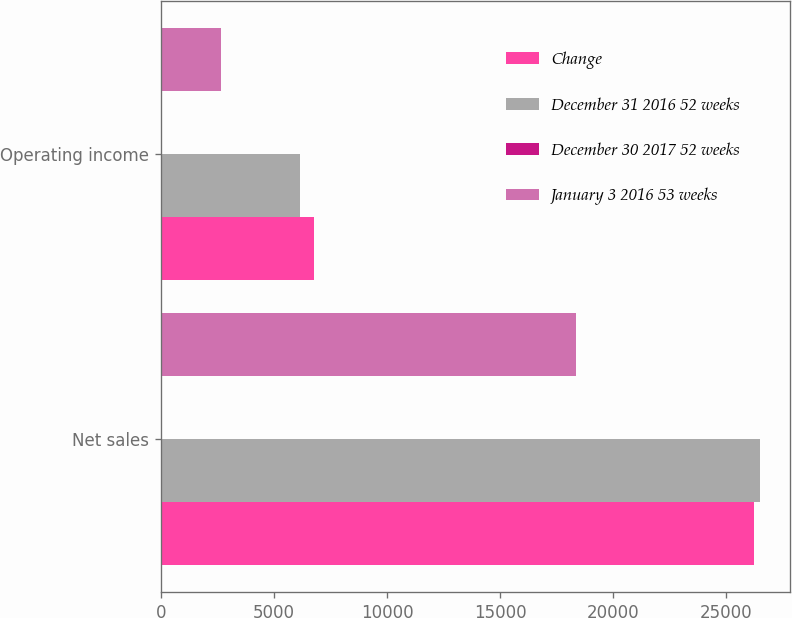Convert chart. <chart><loc_0><loc_0><loc_500><loc_500><stacked_bar_chart><ecel><fcel>Net sales<fcel>Operating income<nl><fcel>Change<fcel>26232<fcel>6773<nl><fcel>December 31 2016 52 weeks<fcel>26487<fcel>6142<nl><fcel>December 30 2017 52 weeks<fcel>1<fcel>10.3<nl><fcel>January 3 2016 53 weeks<fcel>18338<fcel>2639<nl></chart> 